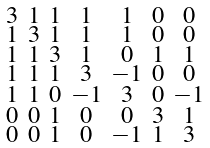Convert formula to latex. <formula><loc_0><loc_0><loc_500><loc_500>\begin{smallmatrix} 3 & 1 & 1 & 1 & 1 & 0 & 0 \\ 1 & 3 & 1 & 1 & 1 & 0 & 0 \\ 1 & 1 & 3 & 1 & 0 & 1 & 1 \\ 1 & 1 & 1 & 3 & - 1 & 0 & 0 \\ 1 & 1 & 0 & - 1 & 3 & 0 & - 1 \\ 0 & 0 & 1 & 0 & 0 & 3 & 1 \\ 0 & 0 & 1 & 0 & - 1 & 1 & 3 \end{smallmatrix}</formula> 